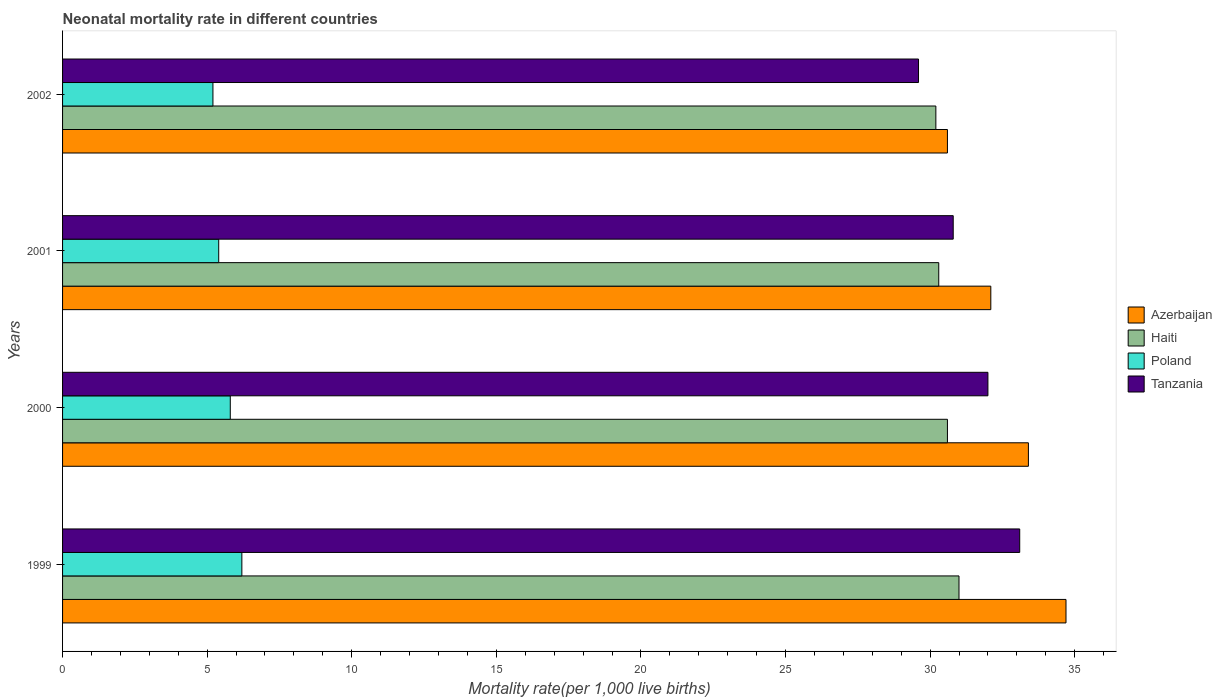How many different coloured bars are there?
Keep it short and to the point. 4. How many groups of bars are there?
Your answer should be compact. 4. Are the number of bars per tick equal to the number of legend labels?
Ensure brevity in your answer.  Yes. In how many cases, is the number of bars for a given year not equal to the number of legend labels?
Keep it short and to the point. 0. What is the neonatal mortality rate in Tanzania in 2002?
Give a very brief answer. 29.6. Across all years, what is the maximum neonatal mortality rate in Azerbaijan?
Your answer should be very brief. 34.7. Across all years, what is the minimum neonatal mortality rate in Azerbaijan?
Provide a short and direct response. 30.6. In which year was the neonatal mortality rate in Azerbaijan maximum?
Your answer should be very brief. 1999. In which year was the neonatal mortality rate in Haiti minimum?
Make the answer very short. 2002. What is the total neonatal mortality rate in Tanzania in the graph?
Your answer should be very brief. 125.5. What is the difference between the neonatal mortality rate in Azerbaijan in 1999 and that in 2001?
Provide a short and direct response. 2.6. What is the difference between the neonatal mortality rate in Haiti in 2000 and the neonatal mortality rate in Poland in 1999?
Your answer should be compact. 24.4. What is the average neonatal mortality rate in Haiti per year?
Provide a short and direct response. 30.53. In the year 1999, what is the difference between the neonatal mortality rate in Poland and neonatal mortality rate in Azerbaijan?
Give a very brief answer. -28.5. In how many years, is the neonatal mortality rate in Haiti greater than 34 ?
Give a very brief answer. 0. What is the ratio of the neonatal mortality rate in Tanzania in 1999 to that in 2001?
Offer a terse response. 1.07. Is the difference between the neonatal mortality rate in Poland in 1999 and 2001 greater than the difference between the neonatal mortality rate in Azerbaijan in 1999 and 2001?
Your answer should be compact. No. What is the difference between the highest and the second highest neonatal mortality rate in Haiti?
Provide a short and direct response. 0.4. In how many years, is the neonatal mortality rate in Haiti greater than the average neonatal mortality rate in Haiti taken over all years?
Your answer should be compact. 2. What does the 2nd bar from the top in 2001 represents?
Keep it short and to the point. Poland. What does the 4th bar from the bottom in 2002 represents?
Offer a terse response. Tanzania. How many bars are there?
Make the answer very short. 16. Are all the bars in the graph horizontal?
Offer a very short reply. Yes. How many years are there in the graph?
Ensure brevity in your answer.  4. What is the difference between two consecutive major ticks on the X-axis?
Ensure brevity in your answer.  5. Are the values on the major ticks of X-axis written in scientific E-notation?
Make the answer very short. No. Where does the legend appear in the graph?
Your answer should be compact. Center right. How many legend labels are there?
Ensure brevity in your answer.  4. How are the legend labels stacked?
Ensure brevity in your answer.  Vertical. What is the title of the graph?
Ensure brevity in your answer.  Neonatal mortality rate in different countries. Does "Nigeria" appear as one of the legend labels in the graph?
Offer a very short reply. No. What is the label or title of the X-axis?
Make the answer very short. Mortality rate(per 1,0 live births). What is the Mortality rate(per 1,000 live births) in Azerbaijan in 1999?
Keep it short and to the point. 34.7. What is the Mortality rate(per 1,000 live births) of Haiti in 1999?
Provide a short and direct response. 31. What is the Mortality rate(per 1,000 live births) in Tanzania in 1999?
Offer a terse response. 33.1. What is the Mortality rate(per 1,000 live births) of Azerbaijan in 2000?
Give a very brief answer. 33.4. What is the Mortality rate(per 1,000 live births) in Haiti in 2000?
Ensure brevity in your answer.  30.6. What is the Mortality rate(per 1,000 live births) of Tanzania in 2000?
Your answer should be very brief. 32. What is the Mortality rate(per 1,000 live births) of Azerbaijan in 2001?
Make the answer very short. 32.1. What is the Mortality rate(per 1,000 live births) in Haiti in 2001?
Your answer should be compact. 30.3. What is the Mortality rate(per 1,000 live births) of Poland in 2001?
Give a very brief answer. 5.4. What is the Mortality rate(per 1,000 live births) of Tanzania in 2001?
Provide a succinct answer. 30.8. What is the Mortality rate(per 1,000 live births) of Azerbaijan in 2002?
Your answer should be very brief. 30.6. What is the Mortality rate(per 1,000 live births) of Haiti in 2002?
Offer a very short reply. 30.2. What is the Mortality rate(per 1,000 live births) in Tanzania in 2002?
Your response must be concise. 29.6. Across all years, what is the maximum Mortality rate(per 1,000 live births) in Azerbaijan?
Your answer should be compact. 34.7. Across all years, what is the maximum Mortality rate(per 1,000 live births) in Tanzania?
Your answer should be very brief. 33.1. Across all years, what is the minimum Mortality rate(per 1,000 live births) in Azerbaijan?
Your answer should be very brief. 30.6. Across all years, what is the minimum Mortality rate(per 1,000 live births) of Haiti?
Your answer should be compact. 30.2. Across all years, what is the minimum Mortality rate(per 1,000 live births) of Poland?
Ensure brevity in your answer.  5.2. Across all years, what is the minimum Mortality rate(per 1,000 live births) of Tanzania?
Offer a very short reply. 29.6. What is the total Mortality rate(per 1,000 live births) of Azerbaijan in the graph?
Offer a very short reply. 130.8. What is the total Mortality rate(per 1,000 live births) in Haiti in the graph?
Ensure brevity in your answer.  122.1. What is the total Mortality rate(per 1,000 live births) in Poland in the graph?
Make the answer very short. 22.6. What is the total Mortality rate(per 1,000 live births) of Tanzania in the graph?
Ensure brevity in your answer.  125.5. What is the difference between the Mortality rate(per 1,000 live births) in Poland in 1999 and that in 2000?
Keep it short and to the point. 0.4. What is the difference between the Mortality rate(per 1,000 live births) of Tanzania in 1999 and that in 2001?
Your answer should be very brief. 2.3. What is the difference between the Mortality rate(per 1,000 live births) in Haiti in 1999 and that in 2002?
Make the answer very short. 0.8. What is the difference between the Mortality rate(per 1,000 live births) in Poland in 1999 and that in 2002?
Provide a succinct answer. 1. What is the difference between the Mortality rate(per 1,000 live births) in Azerbaijan in 2000 and that in 2001?
Give a very brief answer. 1.3. What is the difference between the Mortality rate(per 1,000 live births) of Poland in 2000 and that in 2001?
Your response must be concise. 0.4. What is the difference between the Mortality rate(per 1,000 live births) of Poland in 2000 and that in 2002?
Make the answer very short. 0.6. What is the difference between the Mortality rate(per 1,000 live births) in Tanzania in 2000 and that in 2002?
Your response must be concise. 2.4. What is the difference between the Mortality rate(per 1,000 live births) in Azerbaijan in 2001 and that in 2002?
Your answer should be very brief. 1.5. What is the difference between the Mortality rate(per 1,000 live births) in Tanzania in 2001 and that in 2002?
Keep it short and to the point. 1.2. What is the difference between the Mortality rate(per 1,000 live births) of Azerbaijan in 1999 and the Mortality rate(per 1,000 live births) of Haiti in 2000?
Offer a very short reply. 4.1. What is the difference between the Mortality rate(per 1,000 live births) in Azerbaijan in 1999 and the Mortality rate(per 1,000 live births) in Poland in 2000?
Provide a short and direct response. 28.9. What is the difference between the Mortality rate(per 1,000 live births) of Haiti in 1999 and the Mortality rate(per 1,000 live births) of Poland in 2000?
Provide a succinct answer. 25.2. What is the difference between the Mortality rate(per 1,000 live births) in Haiti in 1999 and the Mortality rate(per 1,000 live births) in Tanzania in 2000?
Keep it short and to the point. -1. What is the difference between the Mortality rate(per 1,000 live births) in Poland in 1999 and the Mortality rate(per 1,000 live births) in Tanzania in 2000?
Your answer should be compact. -25.8. What is the difference between the Mortality rate(per 1,000 live births) in Azerbaijan in 1999 and the Mortality rate(per 1,000 live births) in Haiti in 2001?
Make the answer very short. 4.4. What is the difference between the Mortality rate(per 1,000 live births) of Azerbaijan in 1999 and the Mortality rate(per 1,000 live births) of Poland in 2001?
Keep it short and to the point. 29.3. What is the difference between the Mortality rate(per 1,000 live births) in Azerbaijan in 1999 and the Mortality rate(per 1,000 live births) in Tanzania in 2001?
Provide a short and direct response. 3.9. What is the difference between the Mortality rate(per 1,000 live births) of Haiti in 1999 and the Mortality rate(per 1,000 live births) of Poland in 2001?
Offer a terse response. 25.6. What is the difference between the Mortality rate(per 1,000 live births) in Poland in 1999 and the Mortality rate(per 1,000 live births) in Tanzania in 2001?
Provide a short and direct response. -24.6. What is the difference between the Mortality rate(per 1,000 live births) in Azerbaijan in 1999 and the Mortality rate(per 1,000 live births) in Poland in 2002?
Give a very brief answer. 29.5. What is the difference between the Mortality rate(per 1,000 live births) of Azerbaijan in 1999 and the Mortality rate(per 1,000 live births) of Tanzania in 2002?
Keep it short and to the point. 5.1. What is the difference between the Mortality rate(per 1,000 live births) of Haiti in 1999 and the Mortality rate(per 1,000 live births) of Poland in 2002?
Your answer should be very brief. 25.8. What is the difference between the Mortality rate(per 1,000 live births) in Haiti in 1999 and the Mortality rate(per 1,000 live births) in Tanzania in 2002?
Keep it short and to the point. 1.4. What is the difference between the Mortality rate(per 1,000 live births) in Poland in 1999 and the Mortality rate(per 1,000 live births) in Tanzania in 2002?
Offer a very short reply. -23.4. What is the difference between the Mortality rate(per 1,000 live births) in Azerbaijan in 2000 and the Mortality rate(per 1,000 live births) in Tanzania in 2001?
Your response must be concise. 2.6. What is the difference between the Mortality rate(per 1,000 live births) in Haiti in 2000 and the Mortality rate(per 1,000 live births) in Poland in 2001?
Ensure brevity in your answer.  25.2. What is the difference between the Mortality rate(per 1,000 live births) of Azerbaijan in 2000 and the Mortality rate(per 1,000 live births) of Haiti in 2002?
Offer a terse response. 3.2. What is the difference between the Mortality rate(per 1,000 live births) of Azerbaijan in 2000 and the Mortality rate(per 1,000 live births) of Poland in 2002?
Provide a succinct answer. 28.2. What is the difference between the Mortality rate(per 1,000 live births) of Haiti in 2000 and the Mortality rate(per 1,000 live births) of Poland in 2002?
Ensure brevity in your answer.  25.4. What is the difference between the Mortality rate(per 1,000 live births) of Haiti in 2000 and the Mortality rate(per 1,000 live births) of Tanzania in 2002?
Make the answer very short. 1. What is the difference between the Mortality rate(per 1,000 live births) of Poland in 2000 and the Mortality rate(per 1,000 live births) of Tanzania in 2002?
Provide a short and direct response. -23.8. What is the difference between the Mortality rate(per 1,000 live births) in Azerbaijan in 2001 and the Mortality rate(per 1,000 live births) in Haiti in 2002?
Offer a terse response. 1.9. What is the difference between the Mortality rate(per 1,000 live births) of Azerbaijan in 2001 and the Mortality rate(per 1,000 live births) of Poland in 2002?
Your answer should be compact. 26.9. What is the difference between the Mortality rate(per 1,000 live births) in Azerbaijan in 2001 and the Mortality rate(per 1,000 live births) in Tanzania in 2002?
Keep it short and to the point. 2.5. What is the difference between the Mortality rate(per 1,000 live births) in Haiti in 2001 and the Mortality rate(per 1,000 live births) in Poland in 2002?
Ensure brevity in your answer.  25.1. What is the difference between the Mortality rate(per 1,000 live births) of Haiti in 2001 and the Mortality rate(per 1,000 live births) of Tanzania in 2002?
Your answer should be compact. 0.7. What is the difference between the Mortality rate(per 1,000 live births) in Poland in 2001 and the Mortality rate(per 1,000 live births) in Tanzania in 2002?
Your answer should be very brief. -24.2. What is the average Mortality rate(per 1,000 live births) of Azerbaijan per year?
Keep it short and to the point. 32.7. What is the average Mortality rate(per 1,000 live births) in Haiti per year?
Offer a very short reply. 30.52. What is the average Mortality rate(per 1,000 live births) in Poland per year?
Ensure brevity in your answer.  5.65. What is the average Mortality rate(per 1,000 live births) of Tanzania per year?
Give a very brief answer. 31.38. In the year 1999, what is the difference between the Mortality rate(per 1,000 live births) in Azerbaijan and Mortality rate(per 1,000 live births) in Haiti?
Keep it short and to the point. 3.7. In the year 1999, what is the difference between the Mortality rate(per 1,000 live births) in Azerbaijan and Mortality rate(per 1,000 live births) in Tanzania?
Keep it short and to the point. 1.6. In the year 1999, what is the difference between the Mortality rate(per 1,000 live births) in Haiti and Mortality rate(per 1,000 live births) in Poland?
Make the answer very short. 24.8. In the year 1999, what is the difference between the Mortality rate(per 1,000 live births) in Haiti and Mortality rate(per 1,000 live births) in Tanzania?
Offer a terse response. -2.1. In the year 1999, what is the difference between the Mortality rate(per 1,000 live births) of Poland and Mortality rate(per 1,000 live births) of Tanzania?
Keep it short and to the point. -26.9. In the year 2000, what is the difference between the Mortality rate(per 1,000 live births) of Azerbaijan and Mortality rate(per 1,000 live births) of Haiti?
Provide a short and direct response. 2.8. In the year 2000, what is the difference between the Mortality rate(per 1,000 live births) in Azerbaijan and Mortality rate(per 1,000 live births) in Poland?
Make the answer very short. 27.6. In the year 2000, what is the difference between the Mortality rate(per 1,000 live births) in Haiti and Mortality rate(per 1,000 live births) in Poland?
Make the answer very short. 24.8. In the year 2000, what is the difference between the Mortality rate(per 1,000 live births) in Haiti and Mortality rate(per 1,000 live births) in Tanzania?
Give a very brief answer. -1.4. In the year 2000, what is the difference between the Mortality rate(per 1,000 live births) of Poland and Mortality rate(per 1,000 live births) of Tanzania?
Offer a very short reply. -26.2. In the year 2001, what is the difference between the Mortality rate(per 1,000 live births) in Azerbaijan and Mortality rate(per 1,000 live births) in Poland?
Make the answer very short. 26.7. In the year 2001, what is the difference between the Mortality rate(per 1,000 live births) in Haiti and Mortality rate(per 1,000 live births) in Poland?
Provide a short and direct response. 24.9. In the year 2001, what is the difference between the Mortality rate(per 1,000 live births) in Haiti and Mortality rate(per 1,000 live births) in Tanzania?
Your answer should be very brief. -0.5. In the year 2001, what is the difference between the Mortality rate(per 1,000 live births) of Poland and Mortality rate(per 1,000 live births) of Tanzania?
Provide a short and direct response. -25.4. In the year 2002, what is the difference between the Mortality rate(per 1,000 live births) of Azerbaijan and Mortality rate(per 1,000 live births) of Haiti?
Your answer should be compact. 0.4. In the year 2002, what is the difference between the Mortality rate(per 1,000 live births) of Azerbaijan and Mortality rate(per 1,000 live births) of Poland?
Give a very brief answer. 25.4. In the year 2002, what is the difference between the Mortality rate(per 1,000 live births) of Azerbaijan and Mortality rate(per 1,000 live births) of Tanzania?
Your response must be concise. 1. In the year 2002, what is the difference between the Mortality rate(per 1,000 live births) of Poland and Mortality rate(per 1,000 live births) of Tanzania?
Your response must be concise. -24.4. What is the ratio of the Mortality rate(per 1,000 live births) of Azerbaijan in 1999 to that in 2000?
Give a very brief answer. 1.04. What is the ratio of the Mortality rate(per 1,000 live births) of Haiti in 1999 to that in 2000?
Ensure brevity in your answer.  1.01. What is the ratio of the Mortality rate(per 1,000 live births) in Poland in 1999 to that in 2000?
Provide a short and direct response. 1.07. What is the ratio of the Mortality rate(per 1,000 live births) of Tanzania in 1999 to that in 2000?
Your answer should be very brief. 1.03. What is the ratio of the Mortality rate(per 1,000 live births) of Azerbaijan in 1999 to that in 2001?
Your response must be concise. 1.08. What is the ratio of the Mortality rate(per 1,000 live births) of Haiti in 1999 to that in 2001?
Offer a terse response. 1.02. What is the ratio of the Mortality rate(per 1,000 live births) of Poland in 1999 to that in 2001?
Give a very brief answer. 1.15. What is the ratio of the Mortality rate(per 1,000 live births) in Tanzania in 1999 to that in 2001?
Offer a terse response. 1.07. What is the ratio of the Mortality rate(per 1,000 live births) in Azerbaijan in 1999 to that in 2002?
Keep it short and to the point. 1.13. What is the ratio of the Mortality rate(per 1,000 live births) of Haiti in 1999 to that in 2002?
Your answer should be compact. 1.03. What is the ratio of the Mortality rate(per 1,000 live births) in Poland in 1999 to that in 2002?
Your answer should be very brief. 1.19. What is the ratio of the Mortality rate(per 1,000 live births) in Tanzania in 1999 to that in 2002?
Keep it short and to the point. 1.12. What is the ratio of the Mortality rate(per 1,000 live births) in Azerbaijan in 2000 to that in 2001?
Keep it short and to the point. 1.04. What is the ratio of the Mortality rate(per 1,000 live births) in Haiti in 2000 to that in 2001?
Offer a very short reply. 1.01. What is the ratio of the Mortality rate(per 1,000 live births) of Poland in 2000 to that in 2001?
Your answer should be very brief. 1.07. What is the ratio of the Mortality rate(per 1,000 live births) in Tanzania in 2000 to that in 2001?
Offer a terse response. 1.04. What is the ratio of the Mortality rate(per 1,000 live births) in Azerbaijan in 2000 to that in 2002?
Ensure brevity in your answer.  1.09. What is the ratio of the Mortality rate(per 1,000 live births) of Haiti in 2000 to that in 2002?
Your response must be concise. 1.01. What is the ratio of the Mortality rate(per 1,000 live births) in Poland in 2000 to that in 2002?
Make the answer very short. 1.12. What is the ratio of the Mortality rate(per 1,000 live births) in Tanzania in 2000 to that in 2002?
Your answer should be compact. 1.08. What is the ratio of the Mortality rate(per 1,000 live births) of Azerbaijan in 2001 to that in 2002?
Keep it short and to the point. 1.05. What is the ratio of the Mortality rate(per 1,000 live births) of Tanzania in 2001 to that in 2002?
Provide a succinct answer. 1.04. What is the difference between the highest and the second highest Mortality rate(per 1,000 live births) in Azerbaijan?
Provide a succinct answer. 1.3. What is the difference between the highest and the second highest Mortality rate(per 1,000 live births) of Poland?
Give a very brief answer. 0.4. What is the difference between the highest and the lowest Mortality rate(per 1,000 live births) in Azerbaijan?
Provide a succinct answer. 4.1. What is the difference between the highest and the lowest Mortality rate(per 1,000 live births) in Poland?
Provide a short and direct response. 1. 